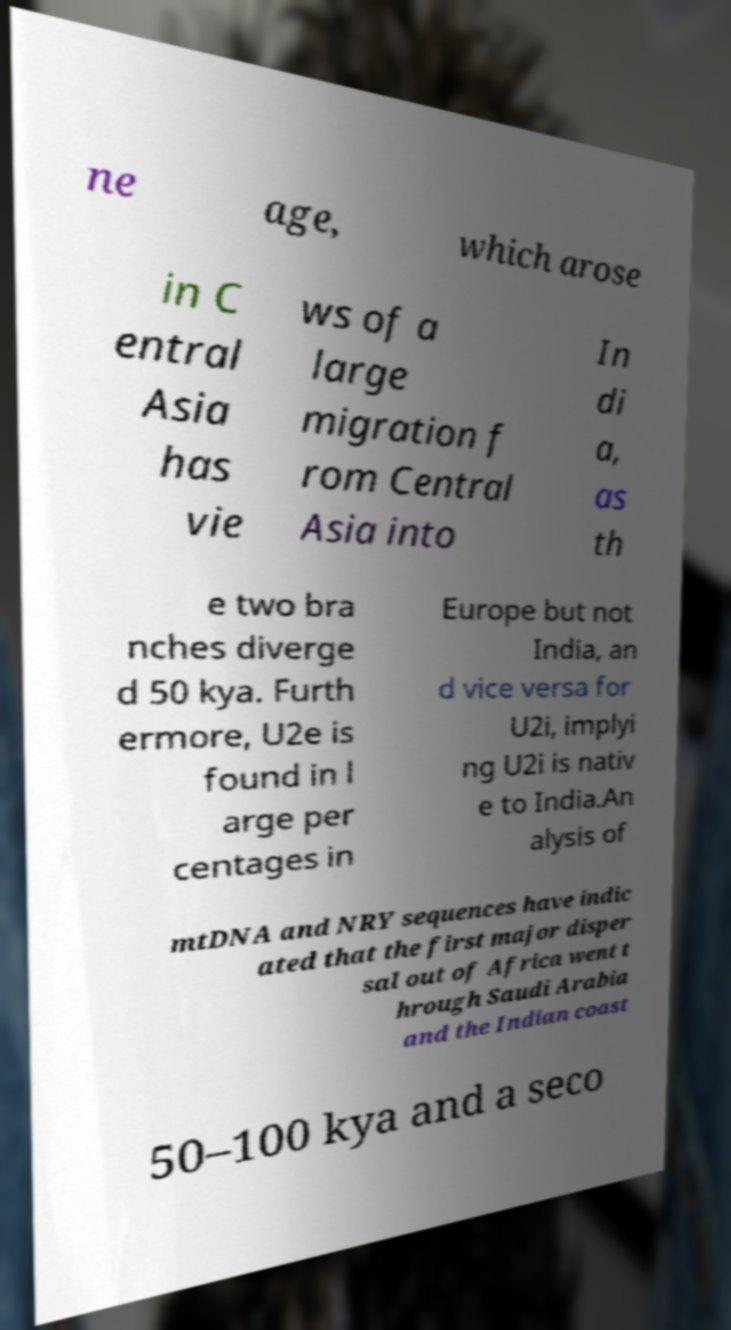Please read and relay the text visible in this image. What does it say? ne age, which arose in C entral Asia has vie ws of a large migration f rom Central Asia into In di a, as th e two bra nches diverge d 50 kya. Furth ermore, U2e is found in l arge per centages in Europe but not India, an d vice versa for U2i, implyi ng U2i is nativ e to India.An alysis of mtDNA and NRY sequences have indic ated that the first major disper sal out of Africa went t hrough Saudi Arabia and the Indian coast 50–100 kya and a seco 